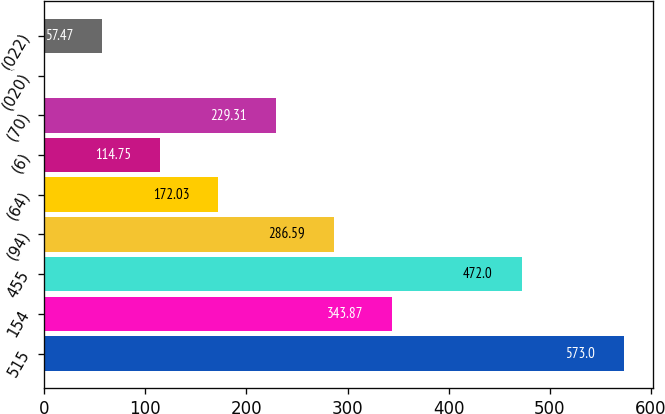<chart> <loc_0><loc_0><loc_500><loc_500><bar_chart><fcel>515<fcel>154<fcel>455<fcel>(94)<fcel>(64)<fcel>(6)<fcel>(70)<fcel>(020)<fcel>(022)<nl><fcel>573<fcel>343.87<fcel>472<fcel>286.59<fcel>172.03<fcel>114.75<fcel>229.31<fcel>0.19<fcel>57.47<nl></chart> 